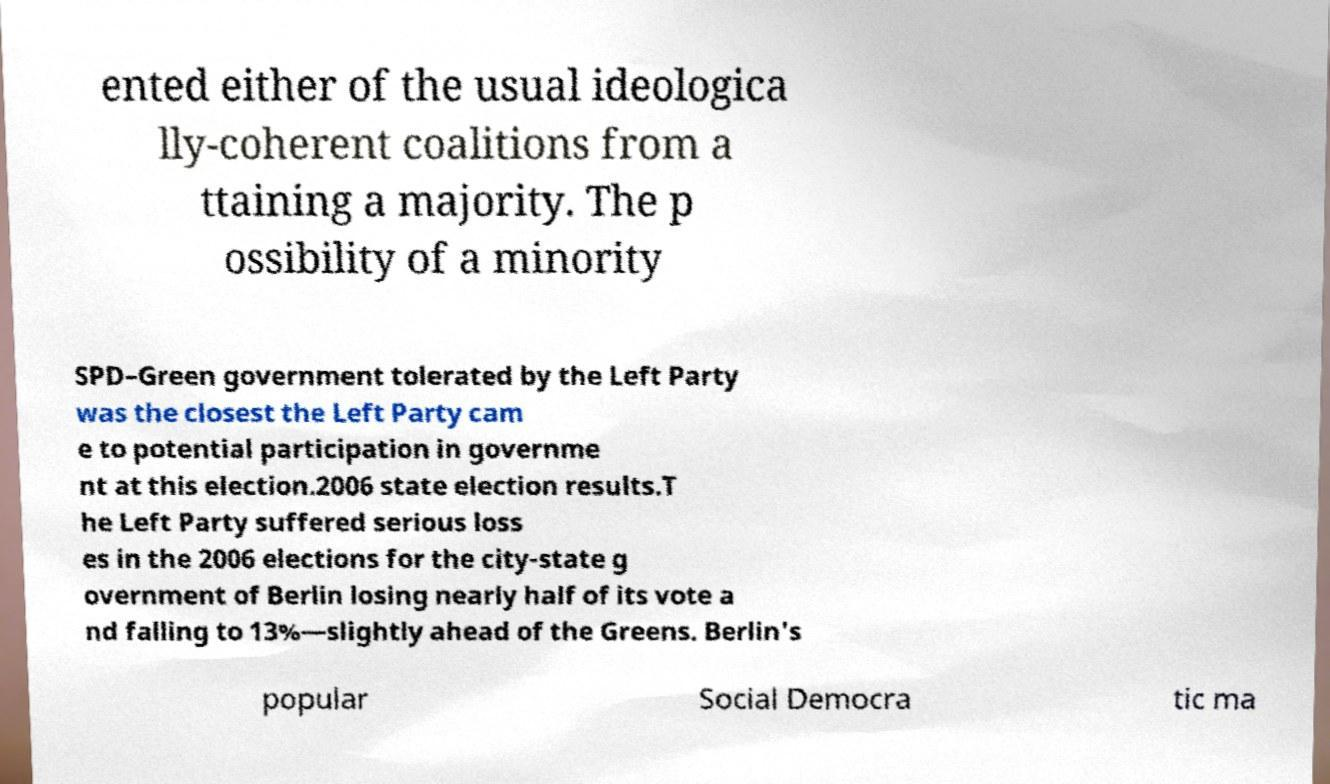What messages or text are displayed in this image? I need them in a readable, typed format. ented either of the usual ideologica lly-coherent coalitions from a ttaining a majority. The p ossibility of a minority SPD–Green government tolerated by the Left Party was the closest the Left Party cam e to potential participation in governme nt at this election.2006 state election results.T he Left Party suffered serious loss es in the 2006 elections for the city-state g overnment of Berlin losing nearly half of its vote a nd falling to 13%—slightly ahead of the Greens. Berlin's popular Social Democra tic ma 